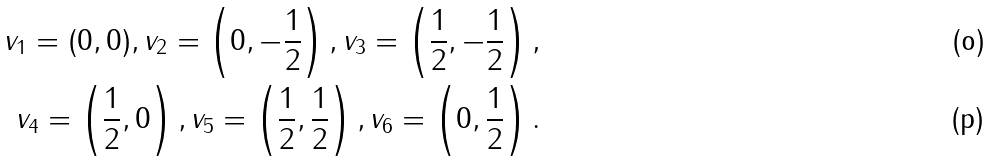<formula> <loc_0><loc_0><loc_500><loc_500>v _ { 1 } = ( 0 , 0 ) , v _ { 2 } = \left ( 0 , - \frac { 1 } { 2 } \right ) , v _ { 3 } = \left ( \frac { 1 } { 2 } , - \frac { 1 } { 2 } \right ) , \\ v _ { 4 } = \left ( \frac { 1 } { 2 } , 0 \right ) , v _ { 5 } = \left ( \frac { 1 } { 2 } , \frac { 1 } { 2 } \right ) , v _ { 6 } = \left ( 0 , \frac { 1 } { 2 } \right ) .</formula> 